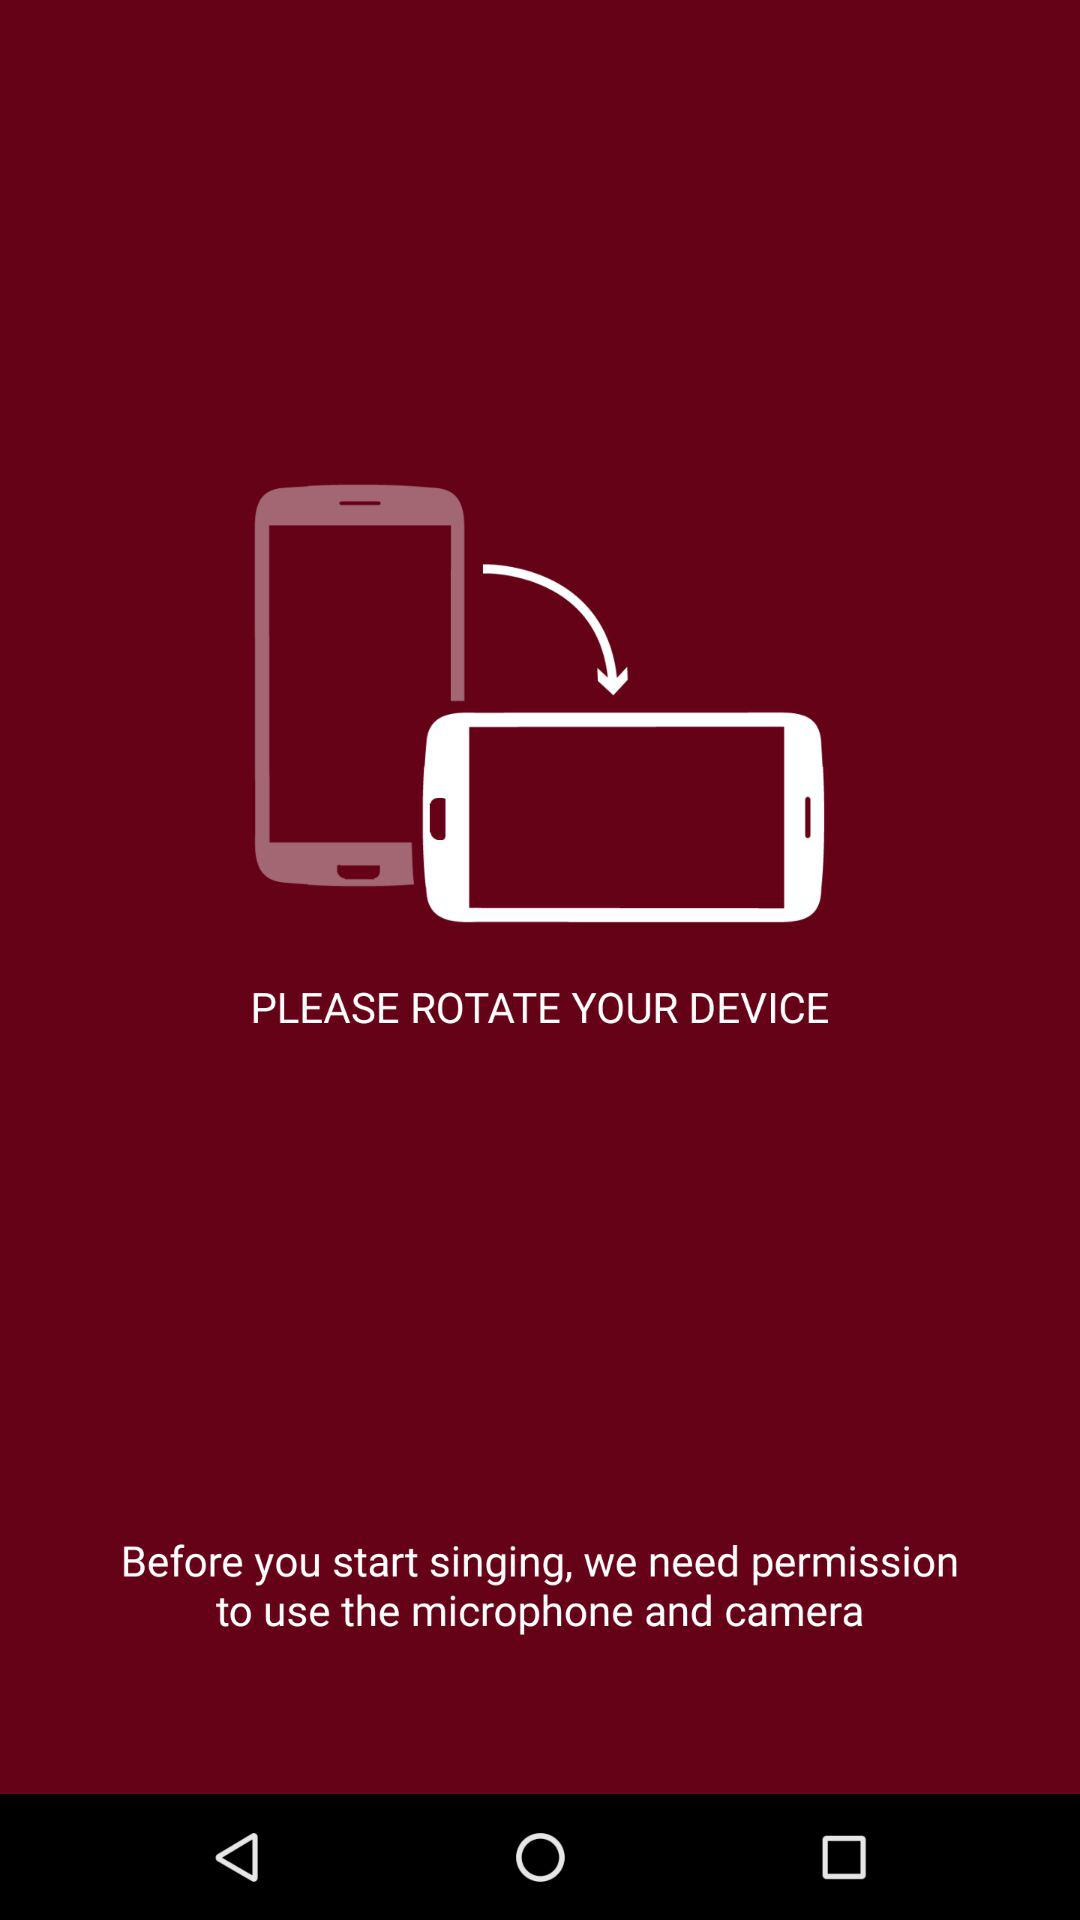What permissions are required before we start singing? We need permission to use the microphone and camera. 